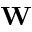Convert formula to latex. <formula><loc_0><loc_0><loc_500><loc_500>W</formula> 